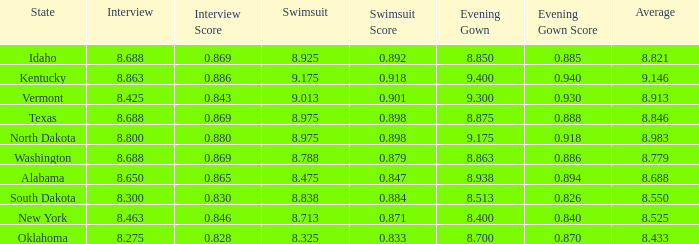What is the lowest evening score of the contestant with an evening gown less than 8.938, from Texas, and with an average less than 8.846 has? None. 